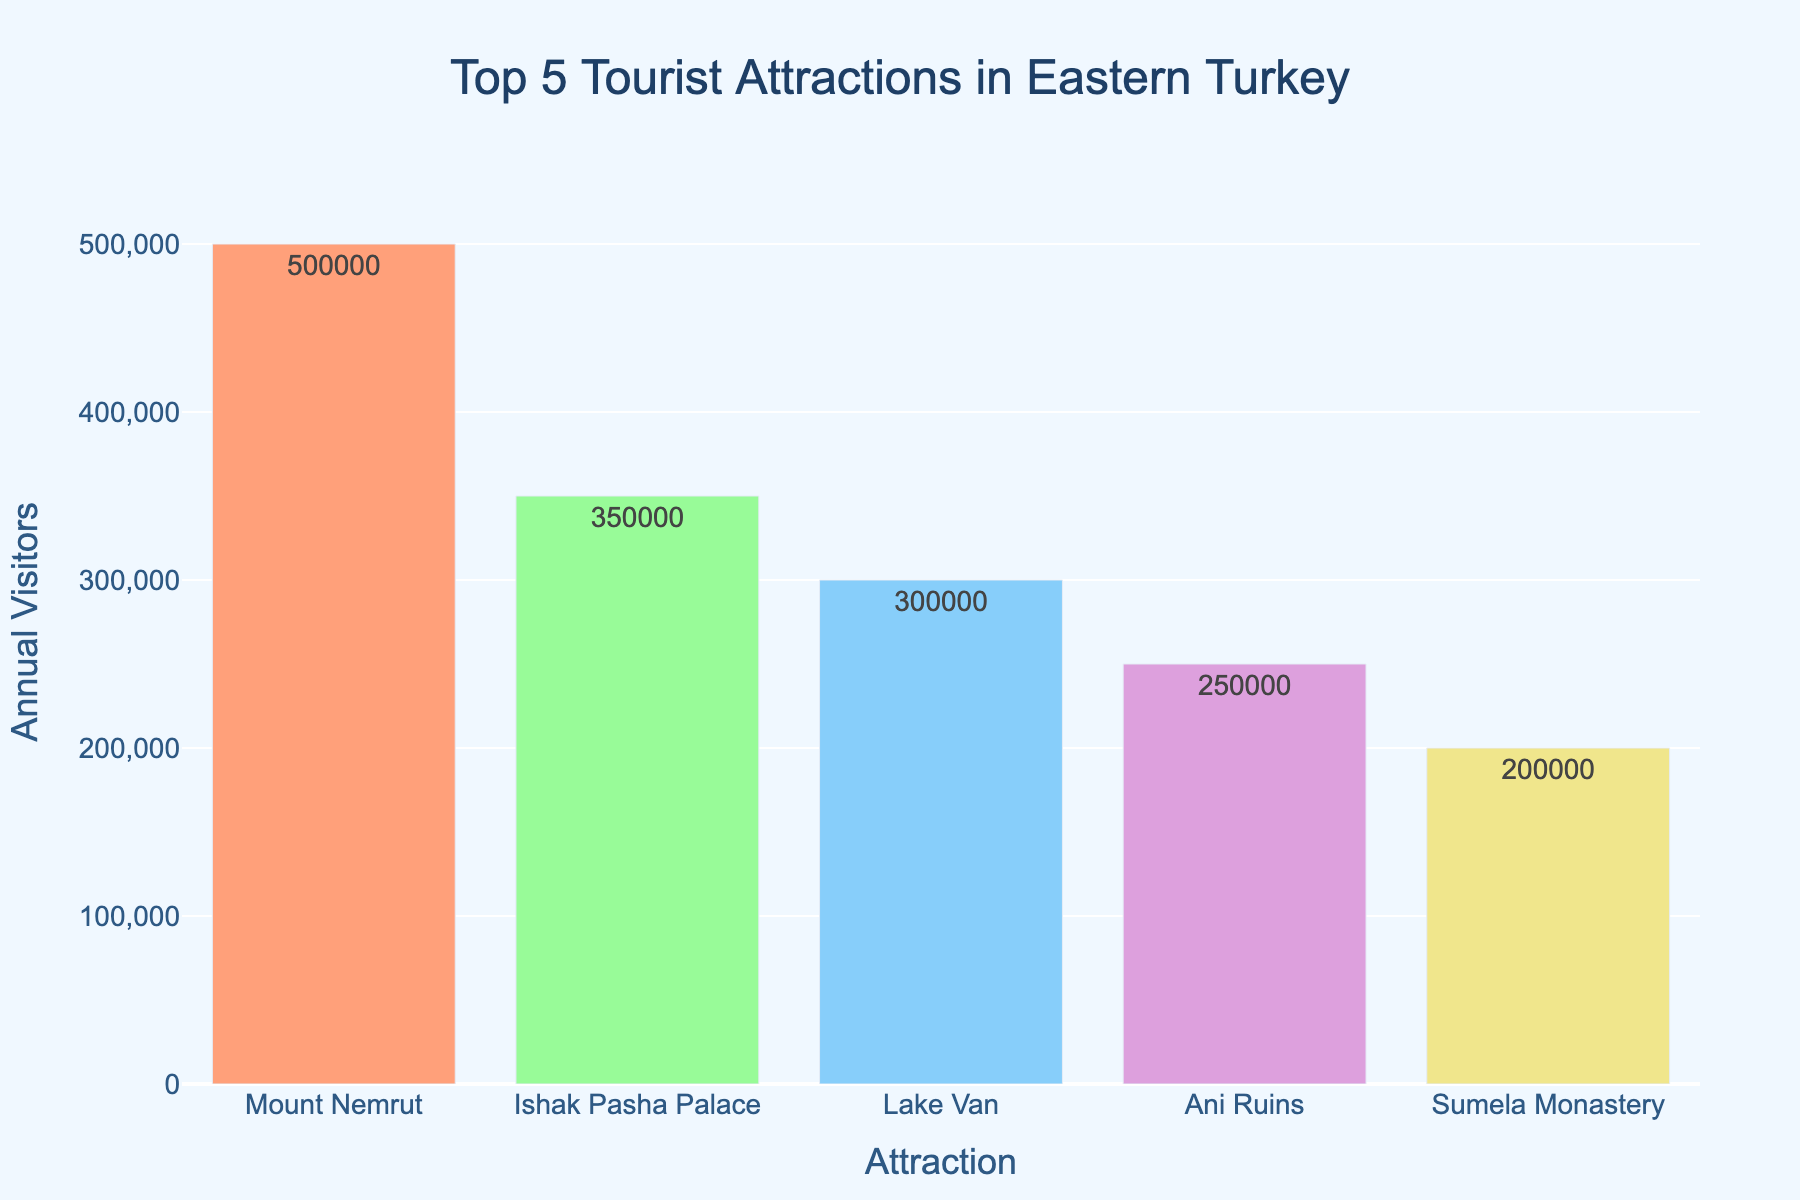Which tourist attraction has the highest number of annual visitors? Look at the bar chart and compare the heights of the bars. The tallest bar represents the attraction with the highest number of visitors. It is Mount Nemrut.
Answer: Mount Nemrut Which tourist attraction has the lowest number of annual visitors? Look at the bar chart and identify the shortest bar. The shortest bar represents the attraction with the lowest number of visitors. It is Sumela Monastery.
Answer: Sumela Monastery What is the total number of visitors for Ani Ruins and Ishak Pasha Palace? Find the visitor numbers for both attractions: Ani Ruins (250,000) and Ishak Pasha Palace (350,000). Sum these numbers: 250,000 + 350,000 = 600,000.
Answer: 600,000 How many more visitors does Mount Nemrut have compared to Lake Van? Find the visitor numbers for both attractions: Mount Nemrut (500,000) and Lake Van (300,000). Subtract the number of visitors for Lake Van from Mount Nemrut: 500,000 - 300,000 = 200,000.
Answer: 200,000 What is the average number of annual visitors for the top 5 attractions? Sum the visitor numbers for all five attractions: 500,000 + 350,000 + 300,000 + 250,000 + 200,000 = 1,600,000. Divide this sum by the number of attractions (5): 1,600,000 / 5 = 320,000.
Answer: 320,000 Which two attractions have the closest number of visitors? Compare the differences between visitor numbers for each pair. The pairs are: Mount Nemrut (500,000) and Ishak Pasha Palace (350,000) - difference of 150,000; Ishak Pasha Palace and Lake Van (300,000) - difference of 50,000; Lake Van and Ani Ruins (250,000) - difference of 50,000; Ani Ruins and Sumela Monastery (200,000) - difference of 50,000. All three comparisons involving Ishak Pasha Palace, Lake Van, and Ani Ruins have a difference of 50,000.
Answer: Ishak Pasha Palace and Lake Van / Lake Van and Ani Ruins / Ani Ruins and Sumela Monastery Are there more visitors to Ani Ruins or Sumela Monastery? Compare the number of visitors: Ani Ruins (250,000) has more visitors than Sumela Monastery (200,000).
Answer: Ani Ruins Which colored bar corresponds to Lake Van? The bar corresponding to Lake Van is sky blue.
Answer: sky blue How many total visitors do the attractions ranked 3rd and 4th have? Find the visitor numbers for the 3rd and 4th ranked attractions: Lake Van (300,000) and Ani Ruins (250,000). Add them together: 300,000 + 250,000 = 550,000.
Answer: 550,000 